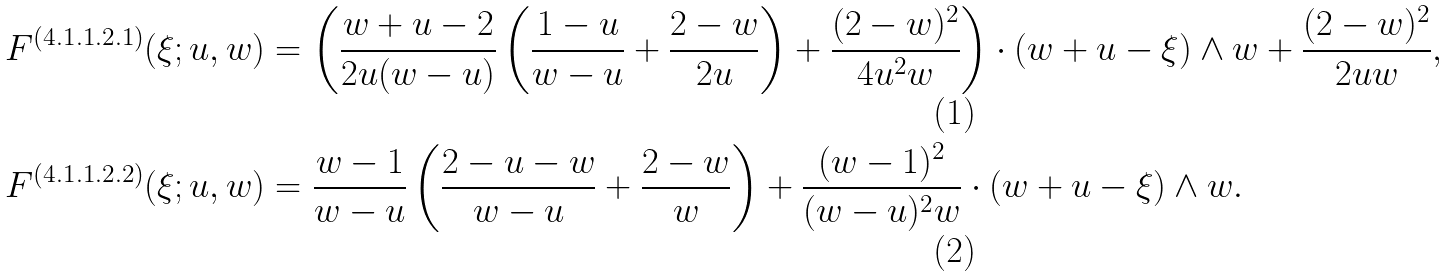<formula> <loc_0><loc_0><loc_500><loc_500>F ^ { ( 4 . 1 . 1 . 2 . 1 ) } ( \xi ; u , w ) & = \left ( \frac { w + u - 2 } { 2 u ( w - u ) } \left ( \frac { 1 - u } { w - u } + \frac { 2 - w } { 2 u } \right ) + \frac { ( 2 - w ) ^ { 2 } } { 4 u ^ { 2 } w } \right ) \cdot ( w + u - \xi ) \wedge w + \frac { ( 2 - w ) ^ { 2 } } { 2 u w } , \\ F ^ { ( 4 . 1 . 1 . 2 . 2 ) } ( \xi ; u , w ) & = \frac { w - 1 } { w - u } \left ( \frac { 2 - u - w } { w - u } + \frac { 2 - w } { w } \right ) + \frac { ( w - 1 ) ^ { 2 } } { ( w - u ) ^ { 2 } w } \cdot ( w + u - \xi ) \wedge w .</formula> 